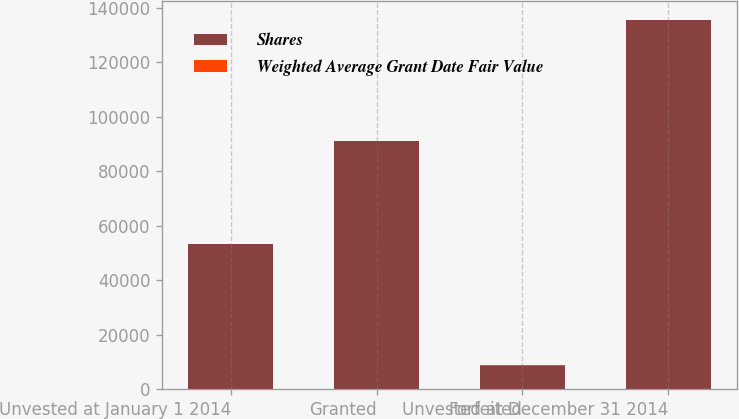<chart> <loc_0><loc_0><loc_500><loc_500><stacked_bar_chart><ecel><fcel>Unvested at January 1 2014<fcel>Granted<fcel>Forfeited<fcel>Unvested at December 31 2014<nl><fcel>Shares<fcel>53205<fcel>91030<fcel>8695<fcel>135540<nl><fcel>Weighted Average Grant Date Fair Value<fcel>59.98<fcel>94.55<fcel>78.26<fcel>81.87<nl></chart> 